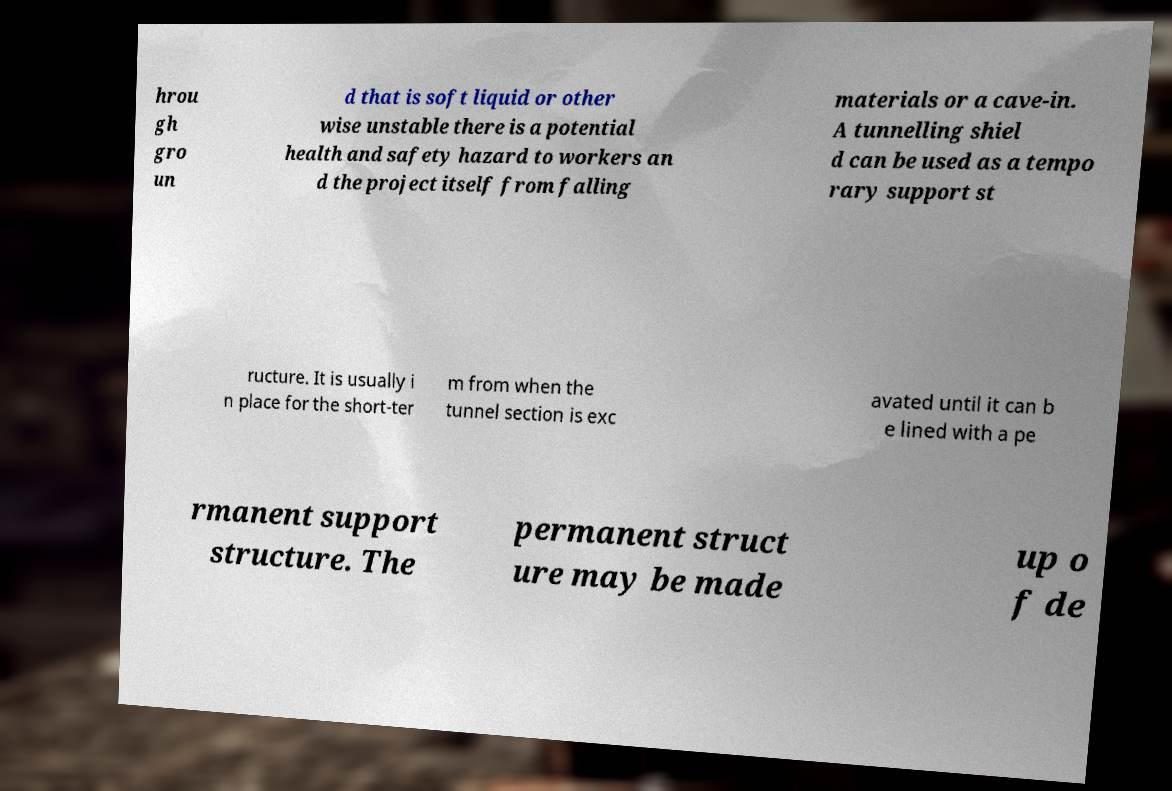Can you accurately transcribe the text from the provided image for me? hrou gh gro un d that is soft liquid or other wise unstable there is a potential health and safety hazard to workers an d the project itself from falling materials or a cave-in. A tunnelling shiel d can be used as a tempo rary support st ructure. It is usually i n place for the short-ter m from when the tunnel section is exc avated until it can b e lined with a pe rmanent support structure. The permanent struct ure may be made up o f de 